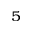Convert formula to latex. <formula><loc_0><loc_0><loc_500><loc_500>_ { 5 }</formula> 